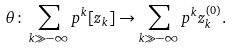Convert formula to latex. <formula><loc_0><loc_0><loc_500><loc_500>\theta \colon \sum _ { k \gg - \infty } p ^ { k } [ z _ { k } ] \rightarrow \sum _ { k \gg - \infty } p ^ { k } z _ { k } ^ { ( 0 ) } .</formula> 